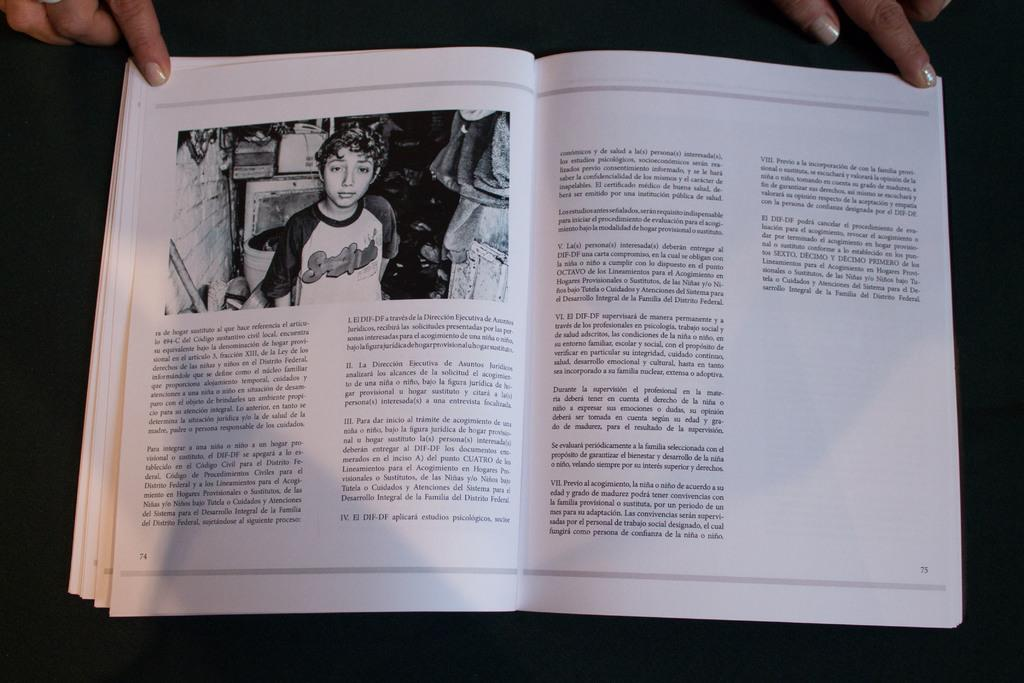Who is present in the image? There is a person in the image. What is the person doing in the image? The person is touching a book. Can you describe the location of the book in the image? The book may be on a table. Where do you think the image was taken? The image is likely taken in a room. What type of fish can be seen swimming in the seashore in the image? There is no fish or seashore present in the image; it features a person touching a book in a room. 